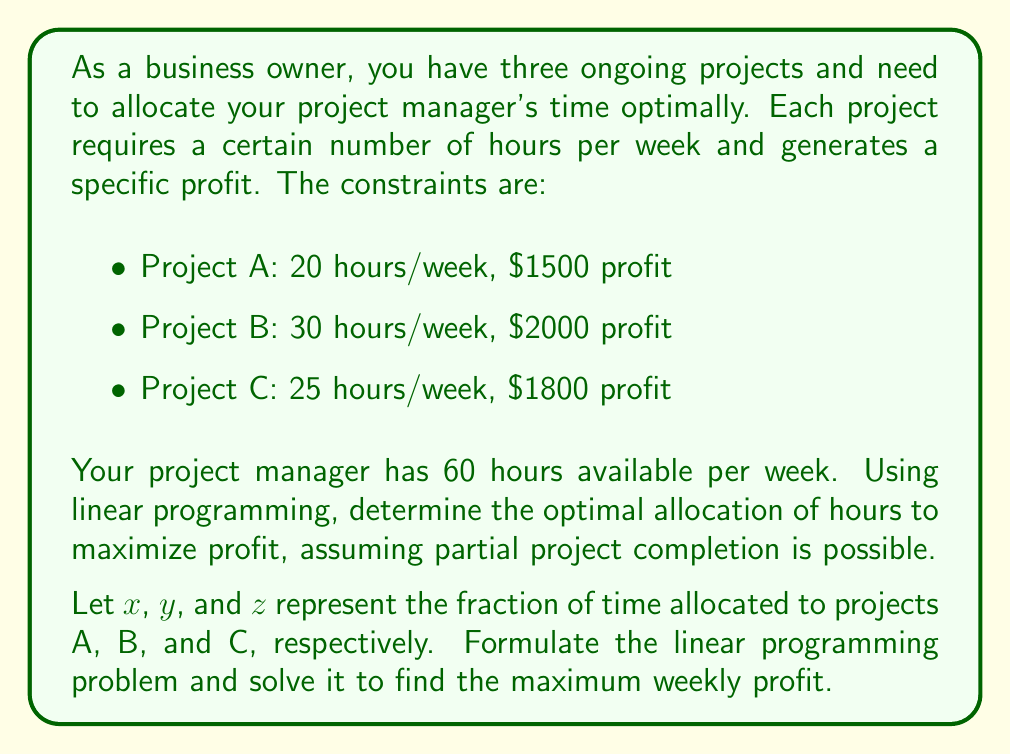Solve this math problem. To solve this linear programming problem, we'll follow these steps:

1. Define variables:
   $x$ = fraction of time allocated to Project A
   $y$ = fraction of time allocated to Project B
   $z$ = fraction of time allocated to Project C

2. Formulate the objective function:
   Maximize profit: $P = 1500x + 2000y + 1800z$

3. Set up constraints:
   Time constraint: $20x + 30y + 25z \leq 60$ (total available hours)
   Non-negativity: $x, y, z \geq 0$
   Upper bounds: $x, y, z \leq 1$ (can't allocate more than 100% to any project)

4. Solve using the simplex method or graphical method. In this case, we'll use the graphical method due to the problem's simplicity.

5. Convert the time constraint to standard form:
   $\frac{x}{3} + \frac{y}{2} + \frac{5z}{12} \leq 1$

6. Plot the feasible region using the constraints and identify corner points:
   (0, 0, 0), (1, 0, 0), (0, 1, 0), (0, 0, 1), (1, 0, 0.44), (0, 1, 0.4), (0.5, 0.5, 0.2)

7. Evaluate the objective function at each corner point:
   (0, 0, 0) → P = 0
   (1, 0, 0) → P = 1500
   (0, 1, 0) → P = 2000
   (0, 0, 1) → P = 1800
   (1, 0, 0.44) → P = 2292
   (0, 1, 0.4) → P = 2720
   (0.5, 0.5, 0.2) → P = 2110

8. The maximum profit occurs at the point (0, 1, 0.4), which means:
   Allocate 100% of time to Project B and 40% of time to Project C

9. Calculate the optimal weekly profit:
   $P = 2000(1) + 1800(0.4) = 2720$
Answer: Optimal allocation: 100% to Project B, 40% to Project C. Maximum weekly profit: $2720. 